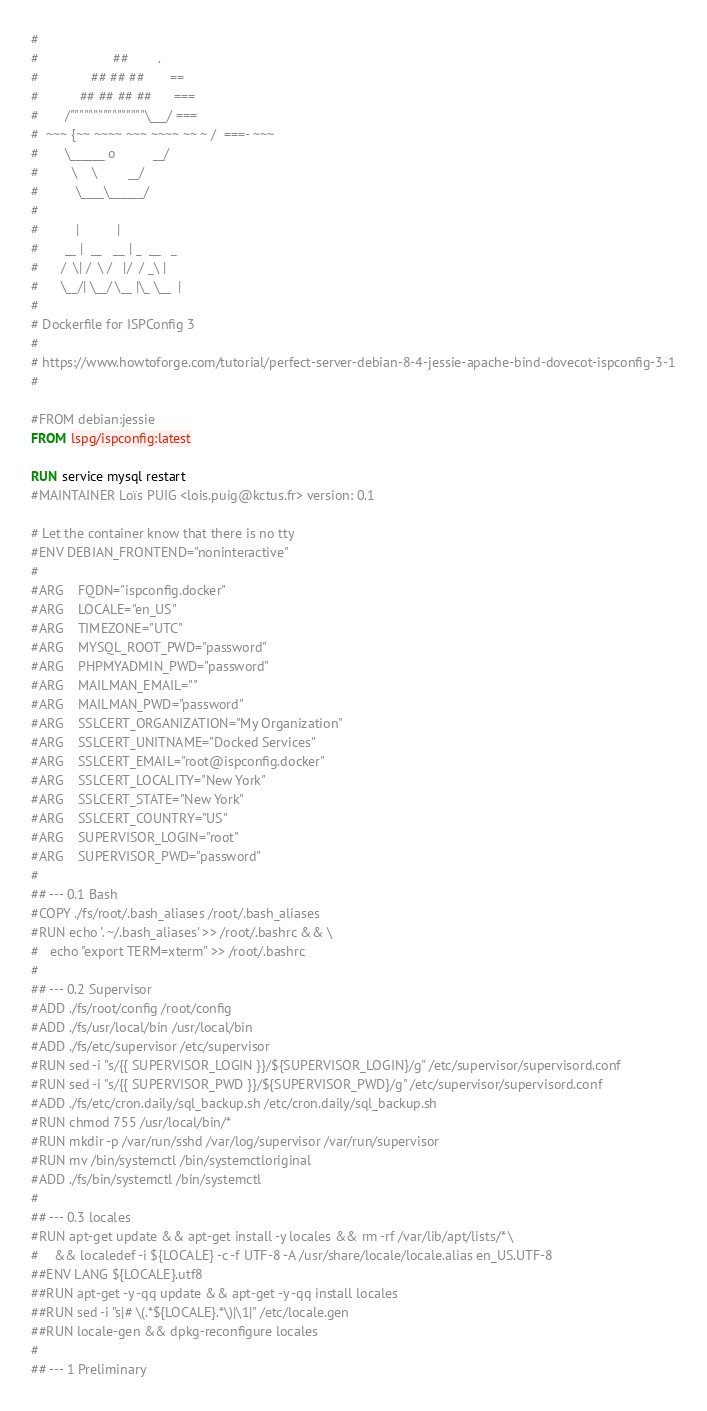<code> <loc_0><loc_0><loc_500><loc_500><_Dockerfile_>#
#                    ##        .
#              ## ## ##       ==
#           ## ## ## ##      ===
#       /""""""""""""""""\___/ ===
#  ~~~ {~~ ~~~~ ~~~ ~~~~ ~~ ~ /  ===- ~~~
#       \______ o          __/
#         \    \        __/
#          \____\______/
#
#          |          |
#       __ |  __   __ | _  __   _
#      /  \| /  \ /   |/  / _\ |
#      \__/| \__/ \__ |\_ \__  |
#
# Dockerfile for ISPConfig 3
#
# https://www.howtoforge.com/tutorial/perfect-server-debian-8-4-jessie-apache-bind-dovecot-ispconfig-3-1
#

#FROM debian:jessie
FROM lspg/ispconfig:latest

RUN service mysql restart
#MAINTAINER Loïs PUIG <lois.puig@kctus.fr> version: 0.1

# Let the container know that there is no tty
#ENV DEBIAN_FRONTEND="noninteractive"
#
#ARG	FQDN="ispconfig.docker"
#ARG	LOCALE="en_US"
#ARG	TIMEZONE="UTC"
#ARG	MYSQL_ROOT_PWD="password"
#ARG	PHPMYADMIN_PWD="password"
#ARG	MAILMAN_EMAIL=""
#ARG	MAILMAN_PWD="password"
#ARG	SSLCERT_ORGANIZATION="My Organization"
#ARG	SSLCERT_UNITNAME="Docked Services"
#ARG	SSLCERT_EMAIL="root@ispconfig.docker"
#ARG	SSLCERT_LOCALITY="New York"
#ARG	SSLCERT_STATE="New York"
#ARG	SSLCERT_COUNTRY="US"
#ARG	SUPERVISOR_LOGIN="root"
#ARG	SUPERVISOR_PWD="password"
#
## --- 0.1 Bash
#COPY ./fs/root/.bash_aliases /root/.bash_aliases
#RUN echo '. ~/.bash_aliases' >> /root/.bashrc && \
#	echo "export TERM=xterm" >> /root/.bashrc
#
## --- 0.2 Supervisor
#ADD ./fs/root/config /root/config
#ADD ./fs/usr/local/bin /usr/local/bin
#ADD ./fs/etc/supervisor /etc/supervisor
#RUN sed -i "s/{{ SUPERVISOR_LOGIN }}/${SUPERVISOR_LOGIN}/g" /etc/supervisor/supervisord.conf
#RUN sed -i "s/{{ SUPERVISOR_PWD }}/${SUPERVISOR_PWD}/g" /etc/supervisor/supervisord.conf
#ADD ./fs/etc/cron.daily/sql_backup.sh /etc/cron.daily/sql_backup.sh
#RUN chmod 755 /usr/local/bin/*
#RUN mkdir -p /var/run/sshd /var/log/supervisor /var/run/supervisor
#RUN mv /bin/systemctl /bin/systemctloriginal
#ADD ./fs/bin/systemctl /bin/systemctl
#
## --- 0.3 locales
#RUN apt-get update && apt-get install -y locales && rm -rf /var/lib/apt/lists/* \
#    && localedef -i ${LOCALE} -c -f UTF-8 -A /usr/share/locale/locale.alias en_US.UTF-8
##ENV LANG ${LOCALE}.utf8
##RUN apt-get -y -qq update && apt-get -y -qq install locales
##RUN sed -i "s|# \(.*${LOCALE}.*\)|\1|" /etc/locale.gen
##RUN locale-gen && dpkg-reconfigure locales
#
## --- 1 Preliminary</code> 